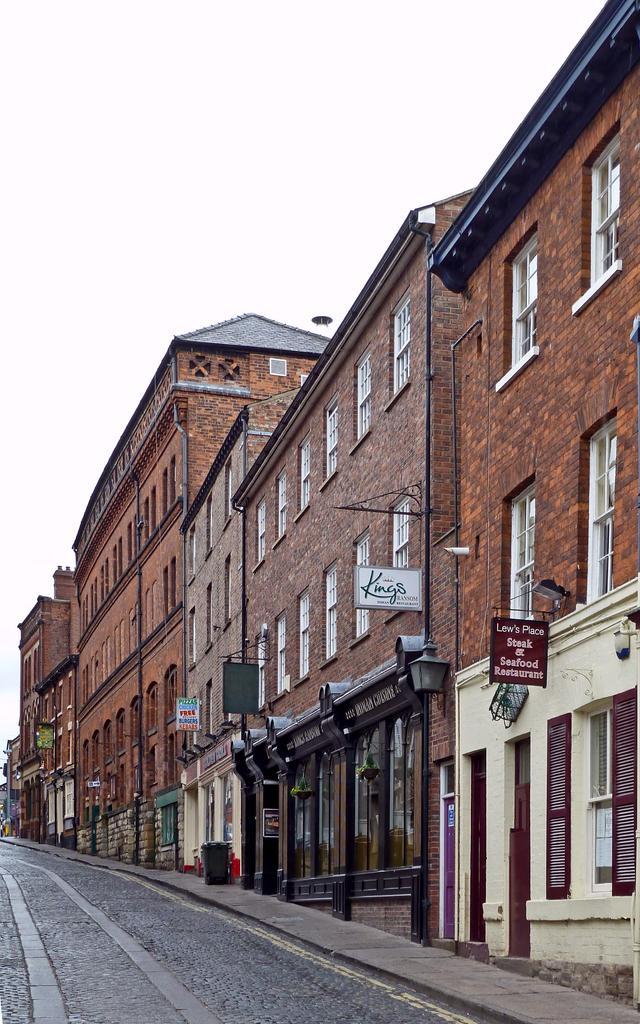Can you describe this image briefly? This is an outside view. At the bottom of the image I can see the road. Beside the road there are many buildings. At the top of the image I can see the sky. 